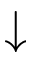<formula> <loc_0><loc_0><loc_500><loc_500>\downarrow</formula> 